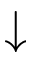<formula> <loc_0><loc_0><loc_500><loc_500>\downarrow</formula> 